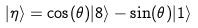<formula> <loc_0><loc_0><loc_500><loc_500>| \eta \rangle = \cos ( \theta ) | 8 \rangle - \sin ( \theta ) | 1 \rangle</formula> 